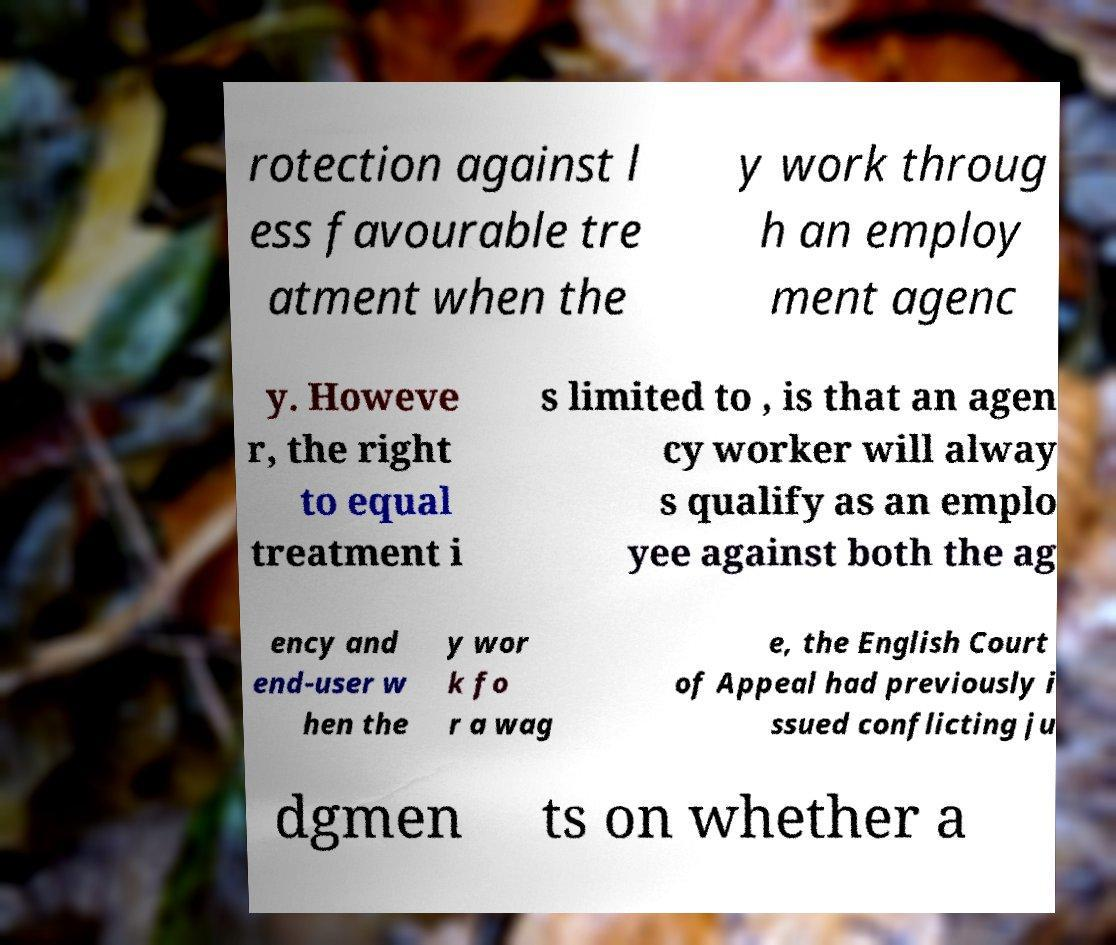Could you extract and type out the text from this image? rotection against l ess favourable tre atment when the y work throug h an employ ment agenc y. Howeve r, the right to equal treatment i s limited to , is that an agen cy worker will alway s qualify as an emplo yee against both the ag ency and end-user w hen the y wor k fo r a wag e, the English Court of Appeal had previously i ssued conflicting ju dgmen ts on whether a 